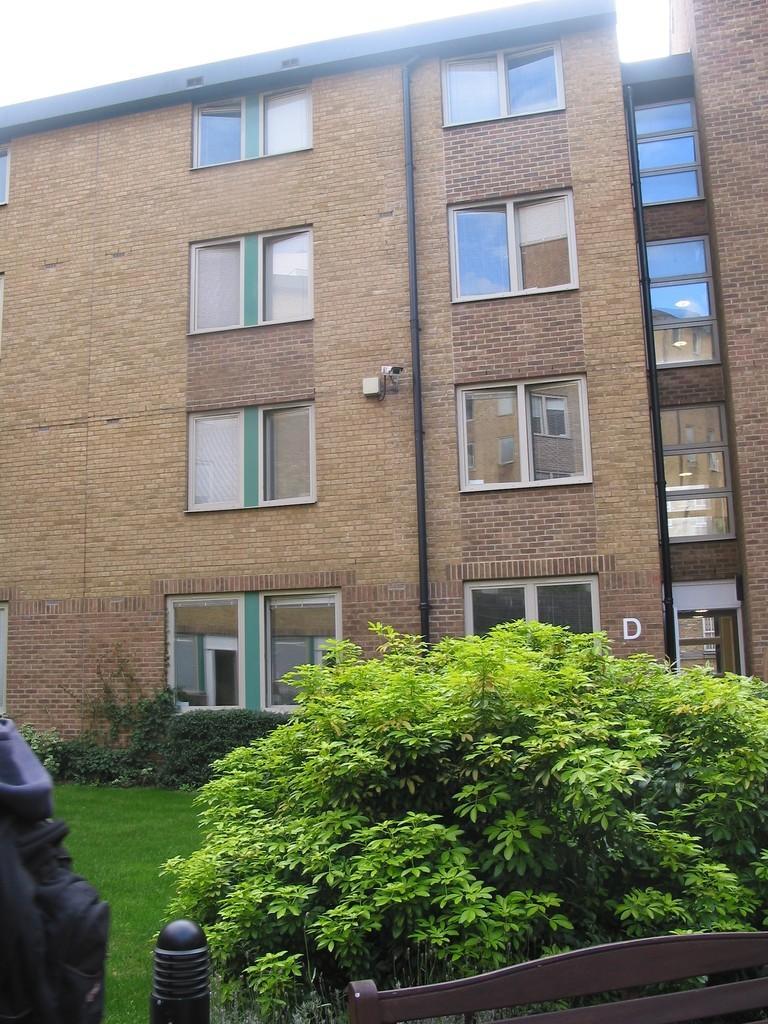Can you describe this image briefly? In the image there is a building in the back with many windows with trees and plants in front of it on the grassland and above its sky. 